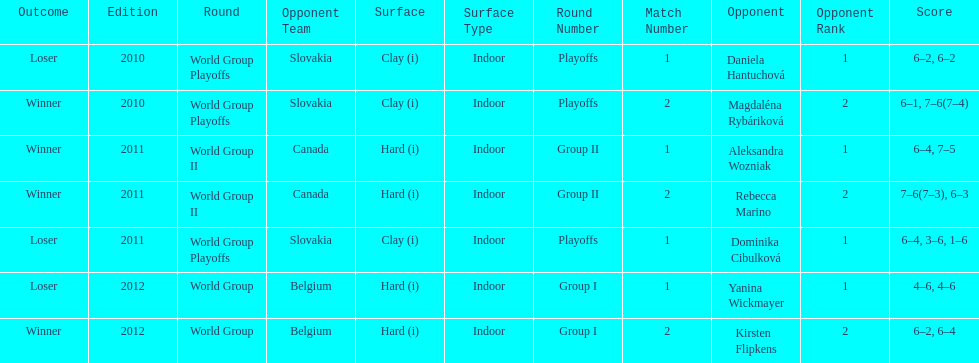What is the other year slovakia played besides 2010? 2011. 